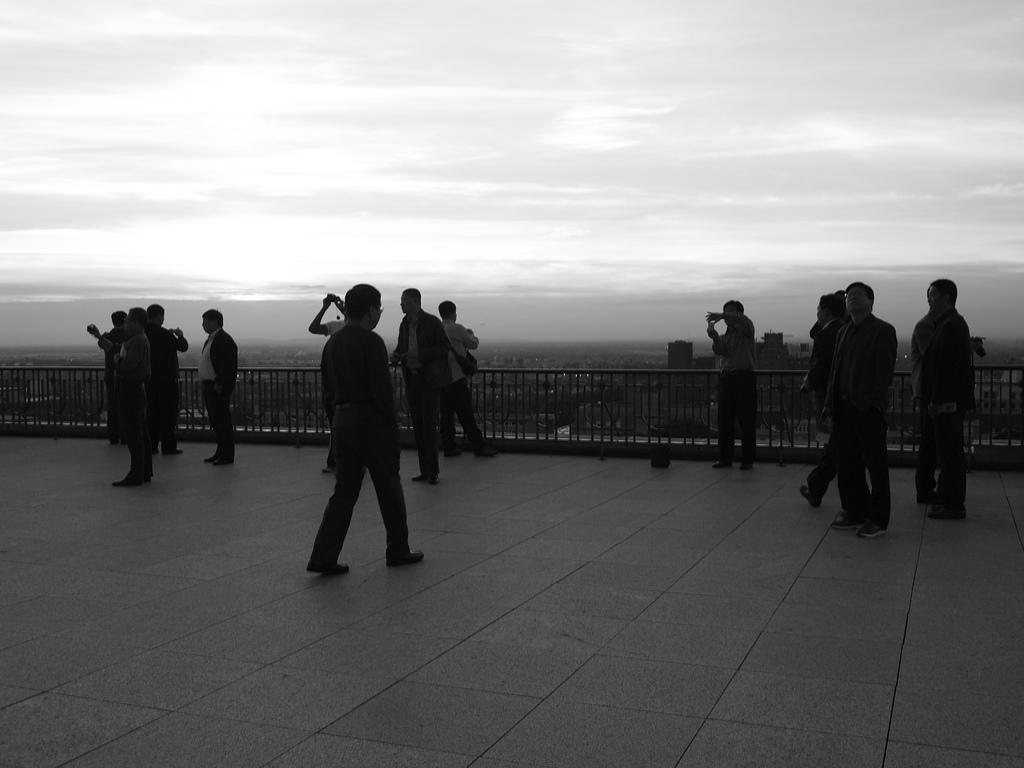Can you describe this image briefly? In this image I can see group of people standing. Also there are iron grilles, buildings and in the background there is sky. 